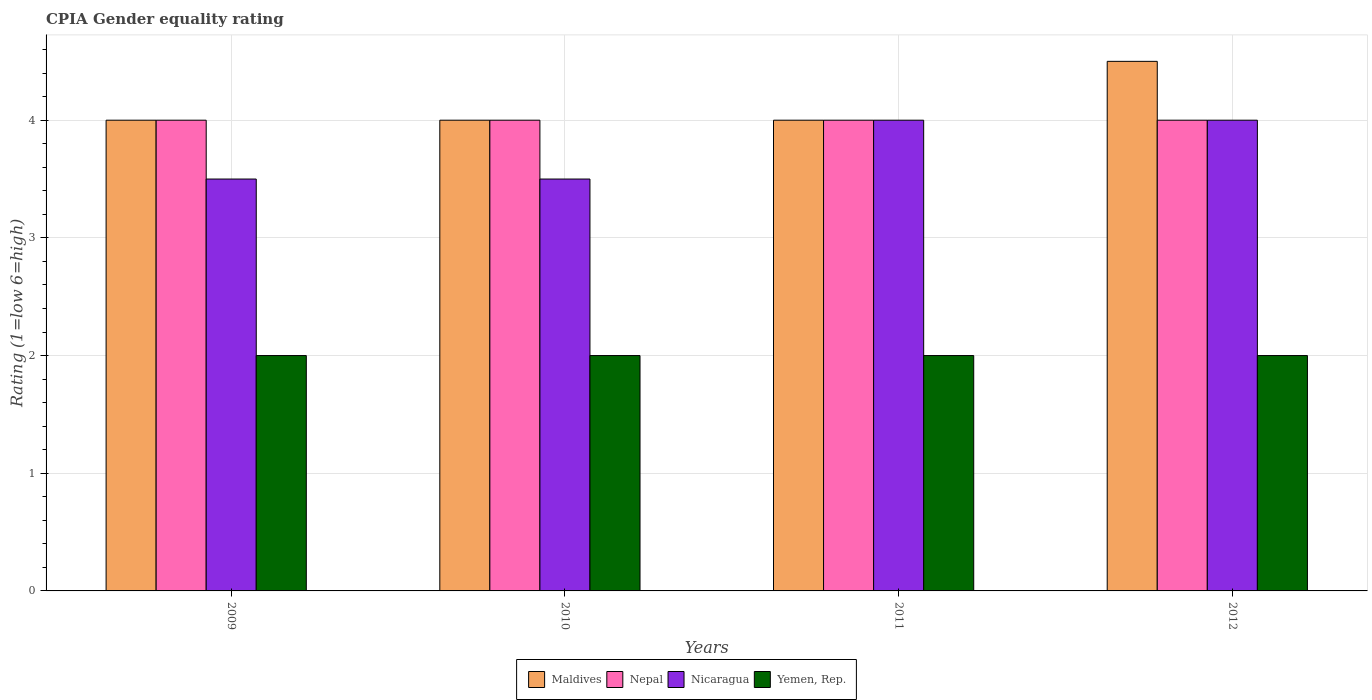How many bars are there on the 1st tick from the left?
Keep it short and to the point. 4. What is the label of the 1st group of bars from the left?
Your answer should be compact. 2009. In how many cases, is the number of bars for a given year not equal to the number of legend labels?
Ensure brevity in your answer.  0. In which year was the CPIA rating in Yemen, Rep. maximum?
Provide a short and direct response. 2009. In which year was the CPIA rating in Nepal minimum?
Keep it short and to the point. 2009. What is the total CPIA rating in Yemen, Rep. in the graph?
Ensure brevity in your answer.  8. In the year 2010, what is the difference between the CPIA rating in Yemen, Rep. and CPIA rating in Nepal?
Your answer should be very brief. -2. What is the ratio of the CPIA rating in Maldives in 2011 to that in 2012?
Ensure brevity in your answer.  0.89. What is the difference between the highest and the lowest CPIA rating in Yemen, Rep.?
Your response must be concise. 0. In how many years, is the CPIA rating in Maldives greater than the average CPIA rating in Maldives taken over all years?
Keep it short and to the point. 1. Is the sum of the CPIA rating in Maldives in 2010 and 2012 greater than the maximum CPIA rating in Nepal across all years?
Ensure brevity in your answer.  Yes. What does the 2nd bar from the left in 2012 represents?
Keep it short and to the point. Nepal. What does the 2nd bar from the right in 2011 represents?
Ensure brevity in your answer.  Nicaragua. Is it the case that in every year, the sum of the CPIA rating in Nepal and CPIA rating in Nicaragua is greater than the CPIA rating in Maldives?
Your answer should be very brief. Yes. Are all the bars in the graph horizontal?
Your response must be concise. No. What is the difference between two consecutive major ticks on the Y-axis?
Offer a very short reply. 1. Does the graph contain any zero values?
Your answer should be compact. No. Where does the legend appear in the graph?
Your answer should be compact. Bottom center. What is the title of the graph?
Your answer should be very brief. CPIA Gender equality rating. What is the label or title of the X-axis?
Provide a short and direct response. Years. What is the Rating (1=low 6=high) of Maldives in 2009?
Your answer should be compact. 4. What is the Rating (1=low 6=high) of Maldives in 2010?
Ensure brevity in your answer.  4. What is the Rating (1=low 6=high) of Nicaragua in 2010?
Provide a short and direct response. 3.5. What is the Rating (1=low 6=high) of Maldives in 2011?
Your answer should be very brief. 4. What is the Rating (1=low 6=high) of Yemen, Rep. in 2011?
Provide a succinct answer. 2. What is the Rating (1=low 6=high) of Nepal in 2012?
Give a very brief answer. 4. What is the Rating (1=low 6=high) in Nicaragua in 2012?
Offer a very short reply. 4. What is the Rating (1=low 6=high) of Yemen, Rep. in 2012?
Your answer should be very brief. 2. Across all years, what is the maximum Rating (1=low 6=high) of Maldives?
Ensure brevity in your answer.  4.5. Across all years, what is the maximum Rating (1=low 6=high) in Nepal?
Your answer should be very brief. 4. Across all years, what is the minimum Rating (1=low 6=high) in Nepal?
Offer a terse response. 4. Across all years, what is the minimum Rating (1=low 6=high) of Nicaragua?
Your answer should be very brief. 3.5. What is the total Rating (1=low 6=high) in Maldives in the graph?
Your answer should be compact. 16.5. What is the total Rating (1=low 6=high) in Nicaragua in the graph?
Your response must be concise. 15. What is the difference between the Rating (1=low 6=high) of Yemen, Rep. in 2009 and that in 2011?
Your answer should be very brief. 0. What is the difference between the Rating (1=low 6=high) in Nepal in 2009 and that in 2012?
Your answer should be very brief. 0. What is the difference between the Rating (1=low 6=high) of Nicaragua in 2009 and that in 2012?
Ensure brevity in your answer.  -0.5. What is the difference between the Rating (1=low 6=high) of Nepal in 2010 and that in 2011?
Make the answer very short. 0. What is the difference between the Rating (1=low 6=high) of Nicaragua in 2010 and that in 2011?
Your response must be concise. -0.5. What is the difference between the Rating (1=low 6=high) of Maldives in 2011 and that in 2012?
Provide a succinct answer. -0.5. What is the difference between the Rating (1=low 6=high) of Yemen, Rep. in 2011 and that in 2012?
Provide a short and direct response. 0. What is the difference between the Rating (1=low 6=high) of Maldives in 2009 and the Rating (1=low 6=high) of Nepal in 2010?
Your response must be concise. 0. What is the difference between the Rating (1=low 6=high) of Nepal in 2009 and the Rating (1=low 6=high) of Nicaragua in 2010?
Your response must be concise. 0.5. What is the difference between the Rating (1=low 6=high) of Maldives in 2009 and the Rating (1=low 6=high) of Nepal in 2011?
Your response must be concise. 0. What is the difference between the Rating (1=low 6=high) of Maldives in 2009 and the Rating (1=low 6=high) of Yemen, Rep. in 2011?
Make the answer very short. 2. What is the difference between the Rating (1=low 6=high) of Nicaragua in 2009 and the Rating (1=low 6=high) of Yemen, Rep. in 2011?
Your response must be concise. 1.5. What is the difference between the Rating (1=low 6=high) of Maldives in 2009 and the Rating (1=low 6=high) of Nepal in 2012?
Offer a very short reply. 0. What is the difference between the Rating (1=low 6=high) of Maldives in 2009 and the Rating (1=low 6=high) of Nicaragua in 2012?
Provide a short and direct response. 0. What is the difference between the Rating (1=low 6=high) in Nepal in 2009 and the Rating (1=low 6=high) in Nicaragua in 2012?
Keep it short and to the point. 0. What is the difference between the Rating (1=low 6=high) in Maldives in 2010 and the Rating (1=low 6=high) in Nepal in 2011?
Your answer should be very brief. 0. What is the difference between the Rating (1=low 6=high) in Maldives in 2010 and the Rating (1=low 6=high) in Nicaragua in 2011?
Your answer should be very brief. 0. What is the difference between the Rating (1=low 6=high) of Nepal in 2010 and the Rating (1=low 6=high) of Nicaragua in 2011?
Give a very brief answer. 0. What is the difference between the Rating (1=low 6=high) in Nicaragua in 2010 and the Rating (1=low 6=high) in Yemen, Rep. in 2011?
Your answer should be very brief. 1.5. What is the difference between the Rating (1=low 6=high) in Maldives in 2010 and the Rating (1=low 6=high) in Nepal in 2012?
Your answer should be very brief. 0. What is the difference between the Rating (1=low 6=high) of Maldives in 2010 and the Rating (1=low 6=high) of Yemen, Rep. in 2012?
Provide a short and direct response. 2. What is the difference between the Rating (1=low 6=high) in Nepal in 2010 and the Rating (1=low 6=high) in Nicaragua in 2012?
Offer a terse response. 0. What is the difference between the Rating (1=low 6=high) of Nepal in 2010 and the Rating (1=low 6=high) of Yemen, Rep. in 2012?
Give a very brief answer. 2. What is the difference between the Rating (1=low 6=high) of Nicaragua in 2010 and the Rating (1=low 6=high) of Yemen, Rep. in 2012?
Give a very brief answer. 1.5. What is the difference between the Rating (1=low 6=high) in Maldives in 2011 and the Rating (1=low 6=high) in Nicaragua in 2012?
Keep it short and to the point. 0. What is the average Rating (1=low 6=high) of Maldives per year?
Your answer should be compact. 4.12. What is the average Rating (1=low 6=high) of Nepal per year?
Your answer should be very brief. 4. What is the average Rating (1=low 6=high) in Nicaragua per year?
Give a very brief answer. 3.75. In the year 2009, what is the difference between the Rating (1=low 6=high) in Maldives and Rating (1=low 6=high) in Nepal?
Ensure brevity in your answer.  0. In the year 2009, what is the difference between the Rating (1=low 6=high) of Nepal and Rating (1=low 6=high) of Nicaragua?
Your answer should be compact. 0.5. In the year 2009, what is the difference between the Rating (1=low 6=high) in Nicaragua and Rating (1=low 6=high) in Yemen, Rep.?
Offer a terse response. 1.5. In the year 2010, what is the difference between the Rating (1=low 6=high) in Maldives and Rating (1=low 6=high) in Nepal?
Keep it short and to the point. 0. In the year 2010, what is the difference between the Rating (1=low 6=high) of Nepal and Rating (1=low 6=high) of Yemen, Rep.?
Give a very brief answer. 2. In the year 2011, what is the difference between the Rating (1=low 6=high) of Maldives and Rating (1=low 6=high) of Nicaragua?
Keep it short and to the point. 0. In the year 2012, what is the difference between the Rating (1=low 6=high) in Maldives and Rating (1=low 6=high) in Nicaragua?
Give a very brief answer. 0.5. In the year 2012, what is the difference between the Rating (1=low 6=high) in Maldives and Rating (1=low 6=high) in Yemen, Rep.?
Keep it short and to the point. 2.5. What is the ratio of the Rating (1=low 6=high) of Nepal in 2009 to that in 2010?
Offer a terse response. 1. What is the ratio of the Rating (1=low 6=high) in Nicaragua in 2009 to that in 2010?
Offer a very short reply. 1. What is the ratio of the Rating (1=low 6=high) in Maldives in 2009 to that in 2011?
Provide a short and direct response. 1. What is the ratio of the Rating (1=low 6=high) in Nicaragua in 2009 to that in 2011?
Ensure brevity in your answer.  0.88. What is the ratio of the Rating (1=low 6=high) in Maldives in 2009 to that in 2012?
Your answer should be very brief. 0.89. What is the ratio of the Rating (1=low 6=high) in Nepal in 2009 to that in 2012?
Make the answer very short. 1. What is the ratio of the Rating (1=low 6=high) in Yemen, Rep. in 2009 to that in 2012?
Keep it short and to the point. 1. What is the ratio of the Rating (1=low 6=high) of Nepal in 2010 to that in 2011?
Provide a short and direct response. 1. What is the ratio of the Rating (1=low 6=high) in Nicaragua in 2010 to that in 2011?
Your response must be concise. 0.88. What is the ratio of the Rating (1=low 6=high) of Yemen, Rep. in 2010 to that in 2011?
Offer a very short reply. 1. What is the ratio of the Rating (1=low 6=high) in Maldives in 2010 to that in 2012?
Offer a very short reply. 0.89. What is the ratio of the Rating (1=low 6=high) of Nepal in 2010 to that in 2012?
Give a very brief answer. 1. What is the ratio of the Rating (1=low 6=high) in Nicaragua in 2010 to that in 2012?
Your answer should be compact. 0.88. What is the ratio of the Rating (1=low 6=high) of Yemen, Rep. in 2010 to that in 2012?
Your answer should be very brief. 1. What is the ratio of the Rating (1=low 6=high) in Nepal in 2011 to that in 2012?
Provide a succinct answer. 1. What is the ratio of the Rating (1=low 6=high) of Yemen, Rep. in 2011 to that in 2012?
Provide a short and direct response. 1. What is the difference between the highest and the second highest Rating (1=low 6=high) of Maldives?
Offer a terse response. 0.5. What is the difference between the highest and the second highest Rating (1=low 6=high) of Nepal?
Keep it short and to the point. 0. What is the difference between the highest and the second highest Rating (1=low 6=high) of Nicaragua?
Provide a succinct answer. 0. What is the difference between the highest and the lowest Rating (1=low 6=high) of Nepal?
Offer a very short reply. 0. What is the difference between the highest and the lowest Rating (1=low 6=high) of Nicaragua?
Your answer should be very brief. 0.5. What is the difference between the highest and the lowest Rating (1=low 6=high) of Yemen, Rep.?
Make the answer very short. 0. 